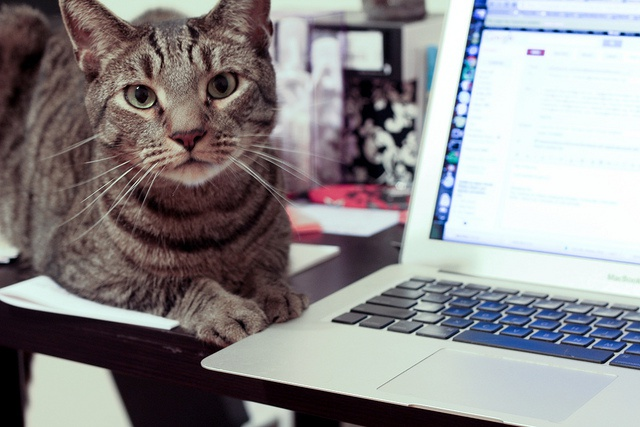Describe the objects in this image and their specific colors. I can see laptop in black, white, darkgray, gray, and blue tones and cat in black, gray, and maroon tones in this image. 